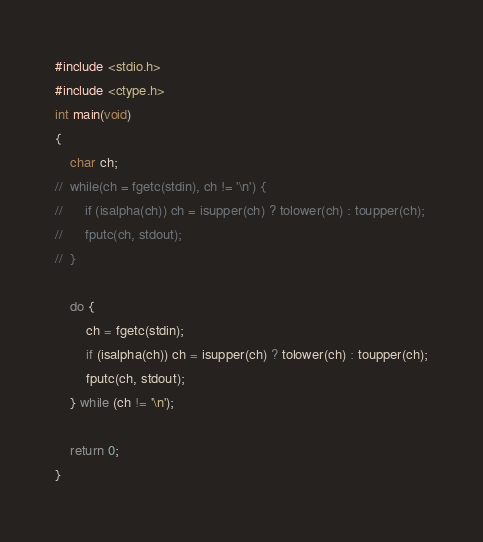<code> <loc_0><loc_0><loc_500><loc_500><_C_>#include <stdio.h>
#include <ctype.h>
int main(void)
{
	char ch;
//	while(ch = fgetc(stdin), ch != '\n') {
//		if (isalpha(ch)) ch = isupper(ch) ? tolower(ch) : toupper(ch);
//		fputc(ch, stdout);
//	}

	do {
		ch = fgetc(stdin);
		if (isalpha(ch)) ch = isupper(ch) ? tolower(ch) : toupper(ch);
		fputc(ch, stdout);
	} while (ch != '\n');
	
	return 0;
}</code> 